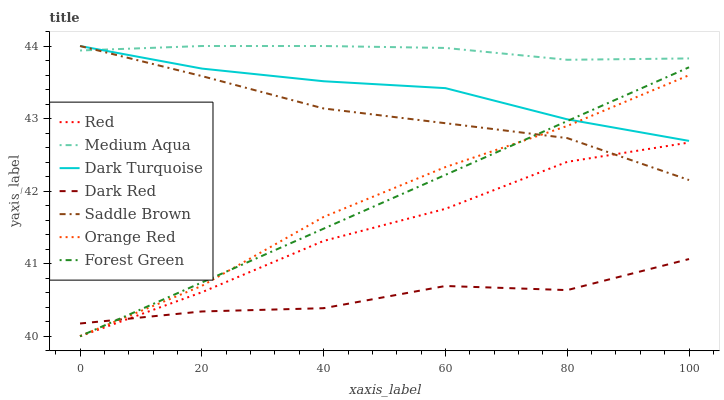Does Dark Red have the minimum area under the curve?
Answer yes or no. Yes. Does Medium Aqua have the maximum area under the curve?
Answer yes or no. Yes. Does Saddle Brown have the minimum area under the curve?
Answer yes or no. No. Does Saddle Brown have the maximum area under the curve?
Answer yes or no. No. Is Forest Green the smoothest?
Answer yes or no. Yes. Is Dark Red the roughest?
Answer yes or no. Yes. Is Saddle Brown the smoothest?
Answer yes or no. No. Is Saddle Brown the roughest?
Answer yes or no. No. Does Forest Green have the lowest value?
Answer yes or no. Yes. Does Saddle Brown have the lowest value?
Answer yes or no. No. Does Medium Aqua have the highest value?
Answer yes or no. Yes. Does Forest Green have the highest value?
Answer yes or no. No. Is Red less than Orange Red?
Answer yes or no. Yes. Is Orange Red greater than Red?
Answer yes or no. Yes. Does Saddle Brown intersect Red?
Answer yes or no. Yes. Is Saddle Brown less than Red?
Answer yes or no. No. Is Saddle Brown greater than Red?
Answer yes or no. No. Does Red intersect Orange Red?
Answer yes or no. No. 